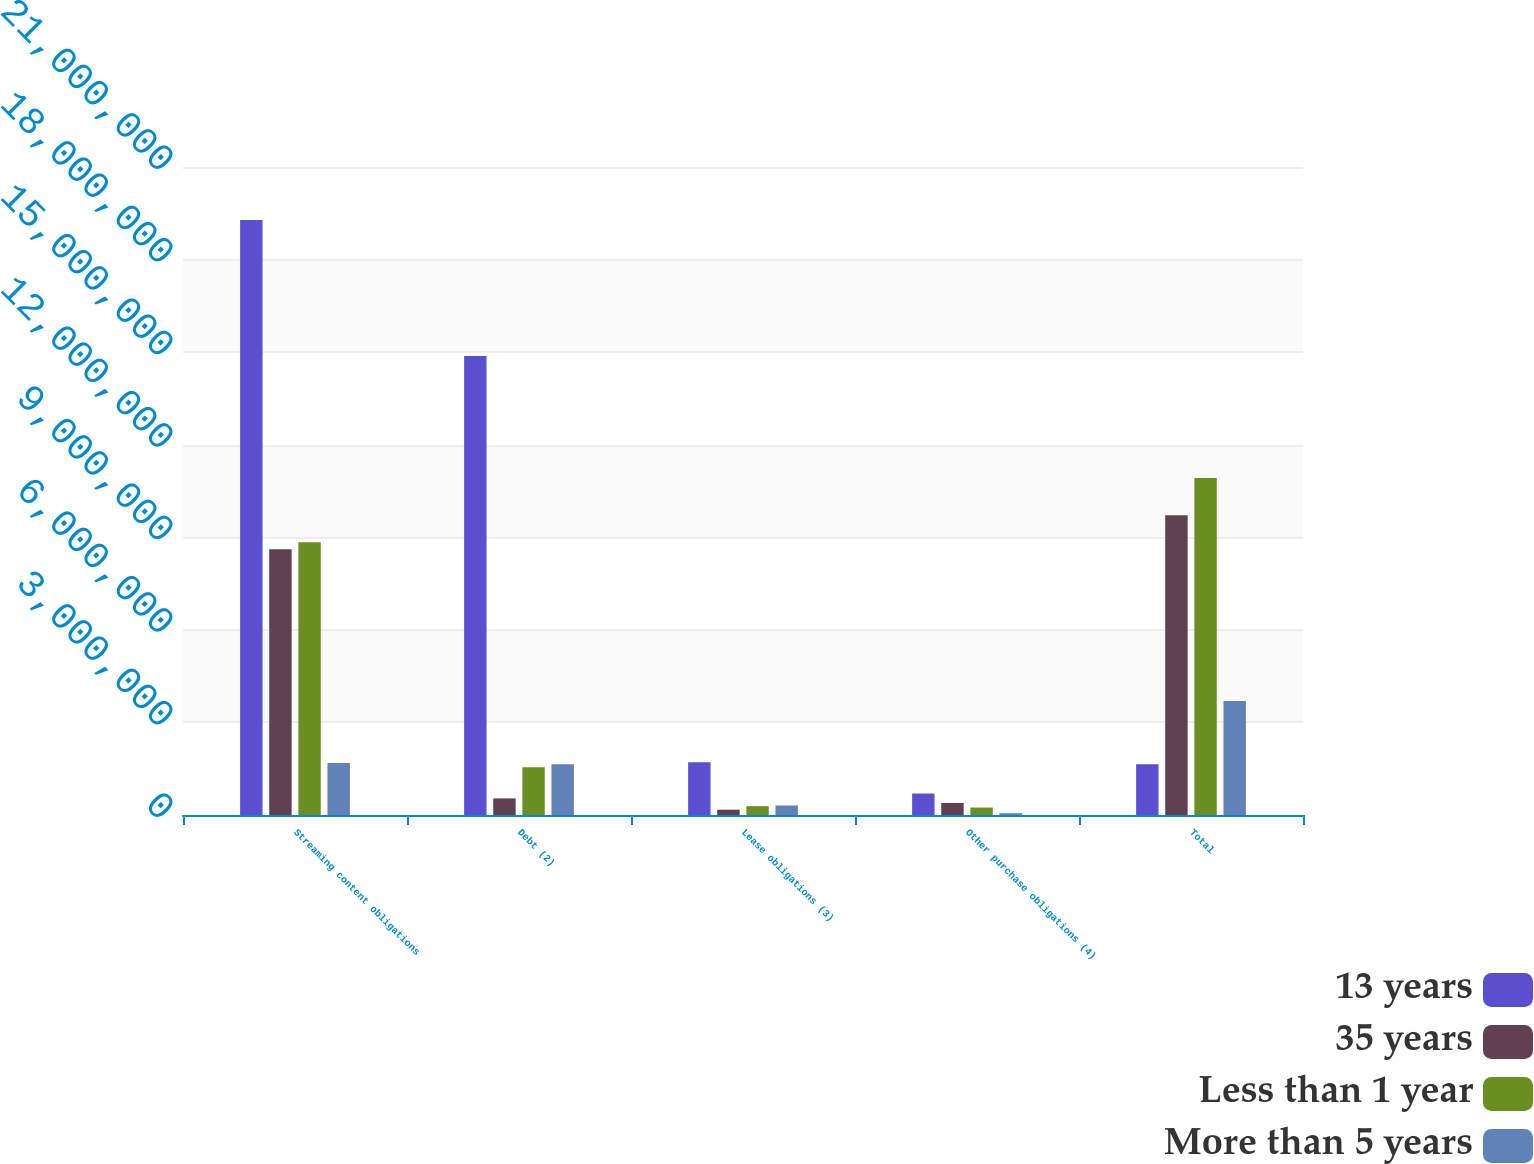Convert chart. <chart><loc_0><loc_0><loc_500><loc_500><stacked_bar_chart><ecel><fcel>Streaming content obligations<fcel>Debt (2)<fcel>Lease obligations (3)<fcel>Other purchase obligations (4)<fcel>Total<nl><fcel>13 years<fcel>1.92859e+07<fcel>1.48732e+07<fcel>1.70837e+06<fcel>696148<fcel>1.6461e+06<nl><fcel>35 years<fcel>8.6114e+06<fcel>538384<fcel>172470<fcel>391025<fcel>9.71328e+06<nl><fcel>Less than 1 year<fcel>8.84156e+06<fcel>1.55058e+06<fcel>284541<fcel>241743<fcel>1.09184e+07<nl><fcel>More than 5 years<fcel>1.68458e+06<fcel>1.6461e+06<fcel>307727<fcel>58212<fcel>3.69662e+06<nl></chart> 